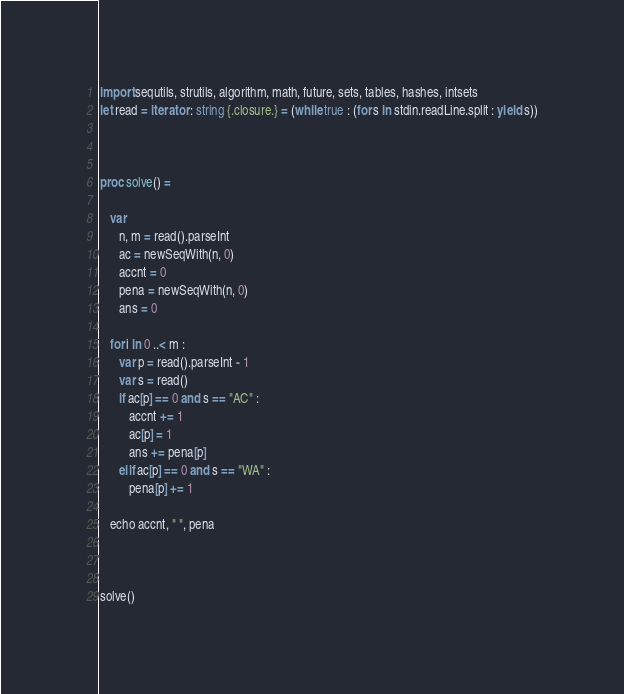Convert code to text. <code><loc_0><loc_0><loc_500><loc_500><_Nim_>import sequtils, strutils, algorithm, math, future, sets, tables, hashes, intsets
let read = iterator : string {.closure.} = (while true : (for s in stdin.readLine.split : yield s))



proc solve() =
   
   var
      n, m = read().parseInt
      ac = newSeqWith(n, 0)
      accnt = 0
      pena = newSeqWith(n, 0)
      ans = 0

   for i in 0 ..< m : 
      var p = read().parseInt - 1
      var s = read()
      if ac[p] == 0 and s == "AC" : 
         accnt += 1
         ac[p] = 1
         ans += pena[p]
      elif ac[p] == 0 and s == "WA" : 
         pena[p] += 1

   echo accnt, " ", pena
      
   

solve()</code> 